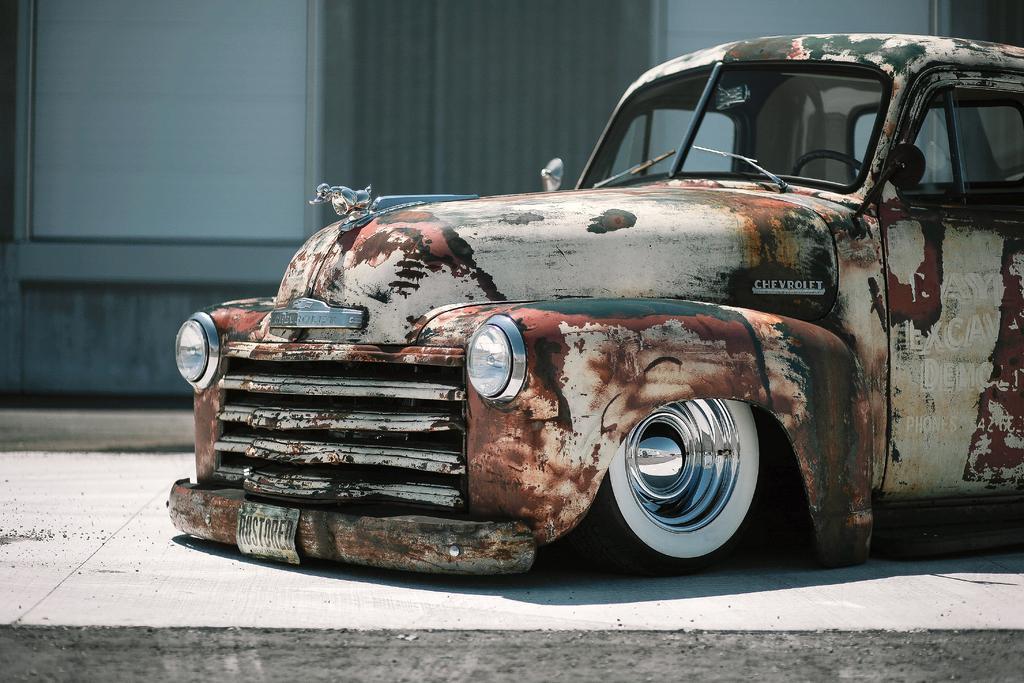In one or two sentences, can you explain what this image depicts? In this image there is a car truncated towards the right of the image, there is ground truncated, at the background of the image there is the wall truncated. 